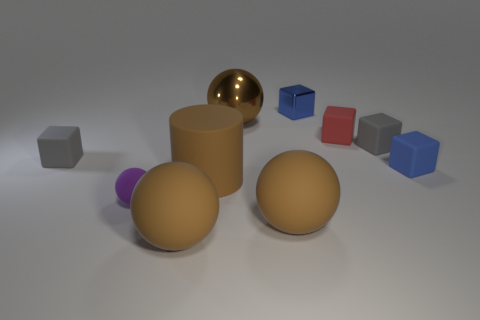Subtract all brown blocks. How many brown balls are left? 3 Subtract all red cubes. How many cubes are left? 4 Subtract all tiny metal blocks. How many blocks are left? 4 Subtract all green cubes. Subtract all purple cylinders. How many cubes are left? 5 Subtract all cylinders. How many objects are left? 9 Add 2 big matte objects. How many big matte objects exist? 5 Subtract 1 red cubes. How many objects are left? 9 Subtract all cubes. Subtract all large objects. How many objects are left? 1 Add 4 matte balls. How many matte balls are left? 7 